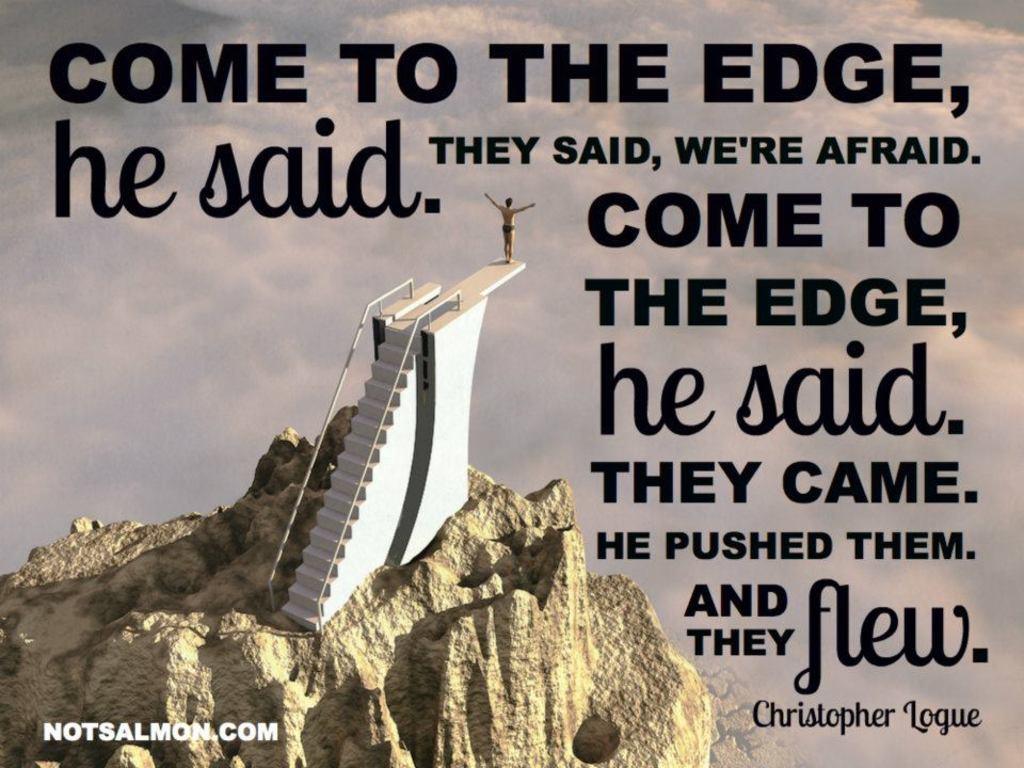<image>
Render a clear and concise summary of the photo. A man standing on a diving board over a cliff from NotSalmon.com 